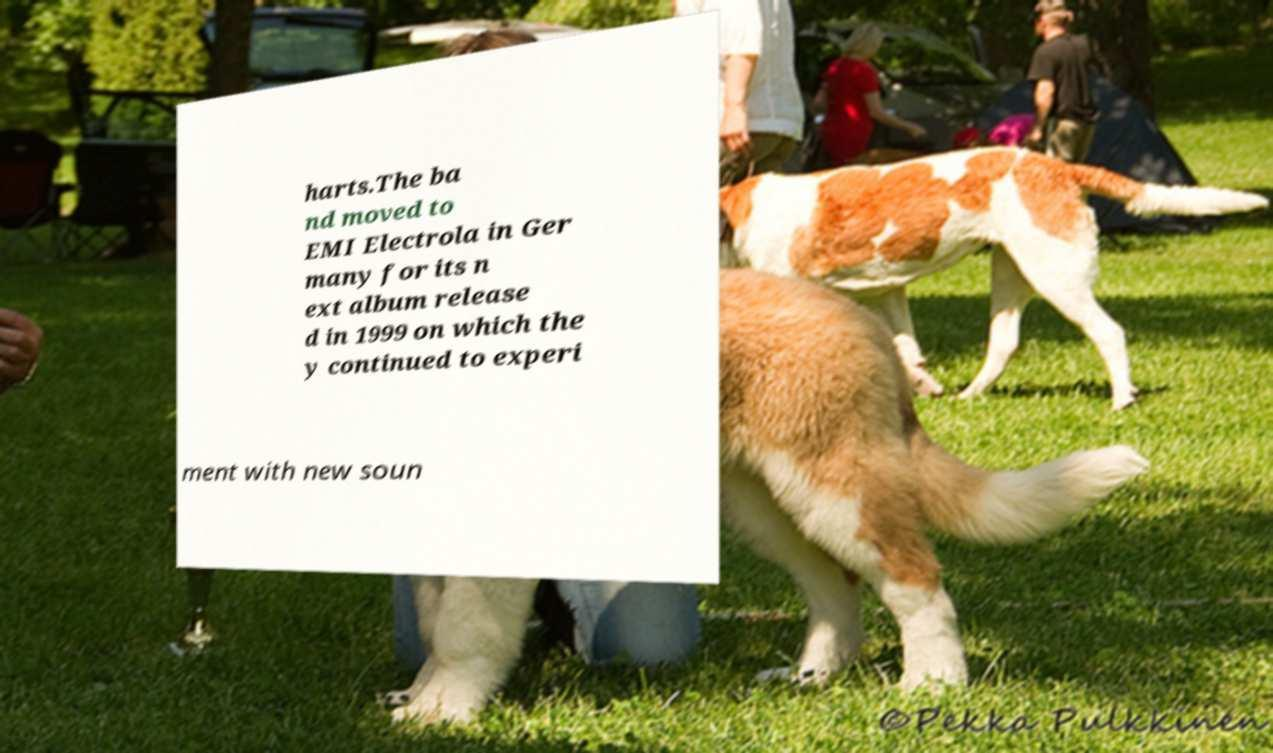For documentation purposes, I need the text within this image transcribed. Could you provide that? harts.The ba nd moved to EMI Electrola in Ger many for its n ext album release d in 1999 on which the y continued to experi ment with new soun 